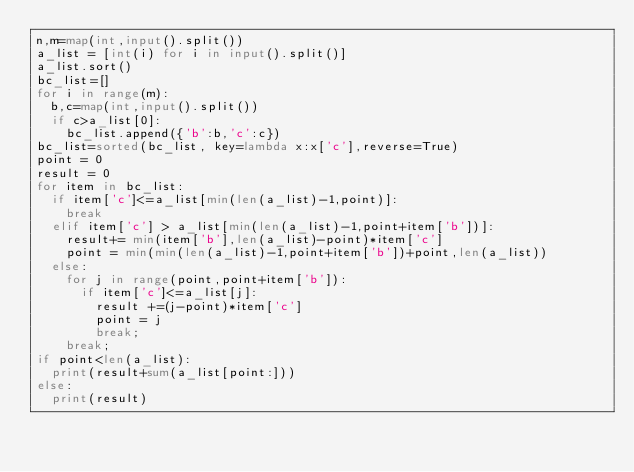<code> <loc_0><loc_0><loc_500><loc_500><_Python_>n,m=map(int,input().split())
a_list = [int(i) for i in input().split()]
a_list.sort()
bc_list=[]
for i in range(m):
	b,c=map(int,input().split())
	if c>a_list[0]:
		bc_list.append({'b':b,'c':c})
bc_list=sorted(bc_list, key=lambda x:x['c'],reverse=True)
point = 0
result = 0
for item in bc_list:
	if item['c']<=a_list[min(len(a_list)-1,point)]:
		break
	elif item['c'] > a_list[min(len(a_list)-1,point+item['b'])]:
		result+= min(item['b'],len(a_list)-point)*item['c']
		point = min(min(len(a_list)-1,point+item['b'])+point,len(a_list))
	else:
		for j in range(point,point+item['b']):
			if item['c']<=a_list[j]:
				result +=(j-point)*item['c']
				point = j
				break;
		break;
if point<len(a_list):
	print(result+sum(a_list[point:]))
else:
	print(result)</code> 